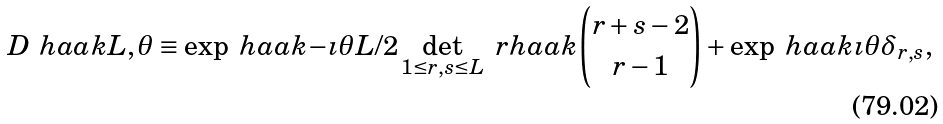Convert formula to latex. <formula><loc_0><loc_0><loc_500><loc_500>D \ h a a k { L , \theta } \equiv \exp \ h a a k { - \imath \theta L / 2 } \det _ { 1 \leq r , s \leq L } \ r h a a k { \binom { r + s - 2 } { r - 1 } + \exp \ h a a k { \imath \theta } \delta _ { r , s } } ,</formula> 